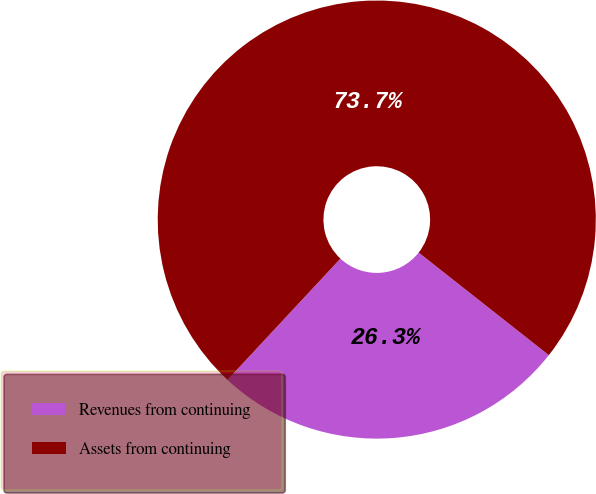Convert chart. <chart><loc_0><loc_0><loc_500><loc_500><pie_chart><fcel>Revenues from continuing<fcel>Assets from continuing<nl><fcel>26.31%<fcel>73.69%<nl></chart> 